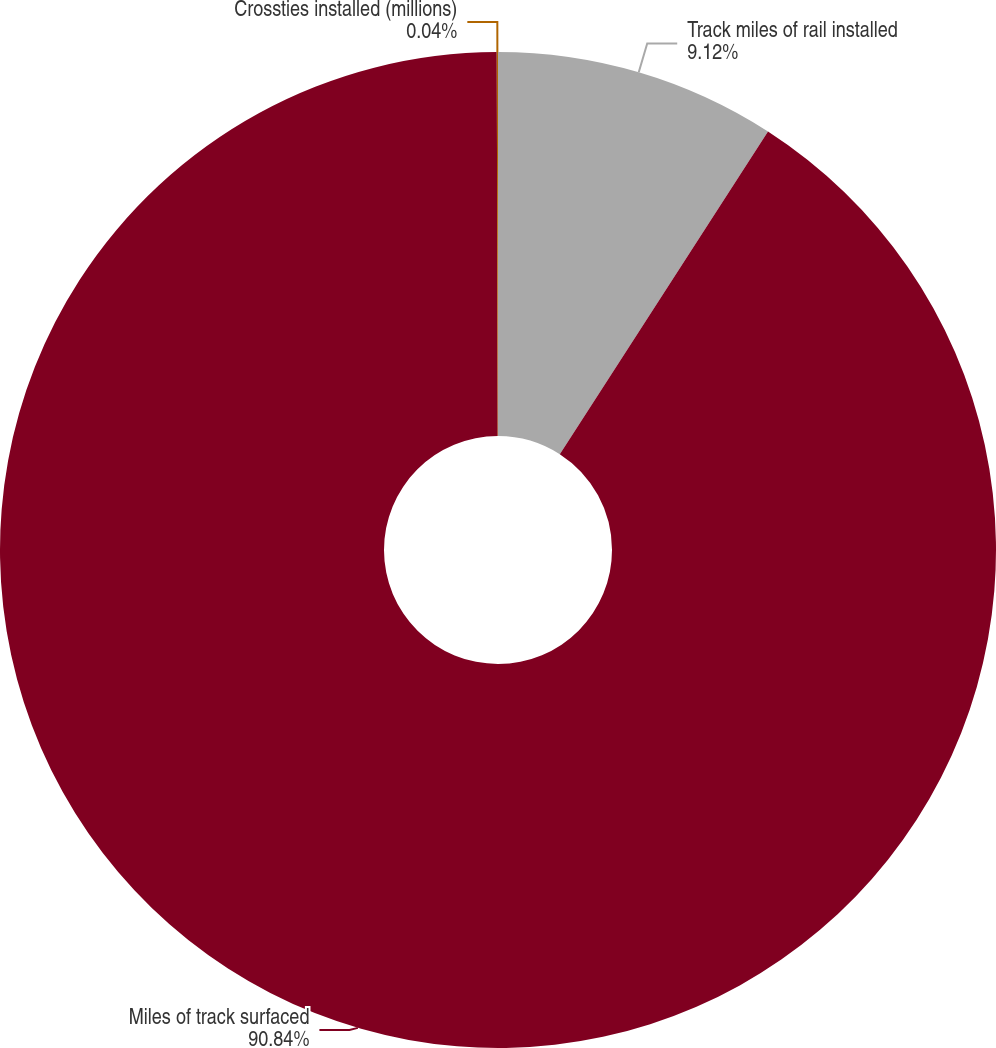Convert chart to OTSL. <chart><loc_0><loc_0><loc_500><loc_500><pie_chart><fcel>Track miles of rail installed<fcel>Miles of track surfaced<fcel>Crossties installed (millions)<nl><fcel>9.12%<fcel>90.84%<fcel>0.04%<nl></chart> 